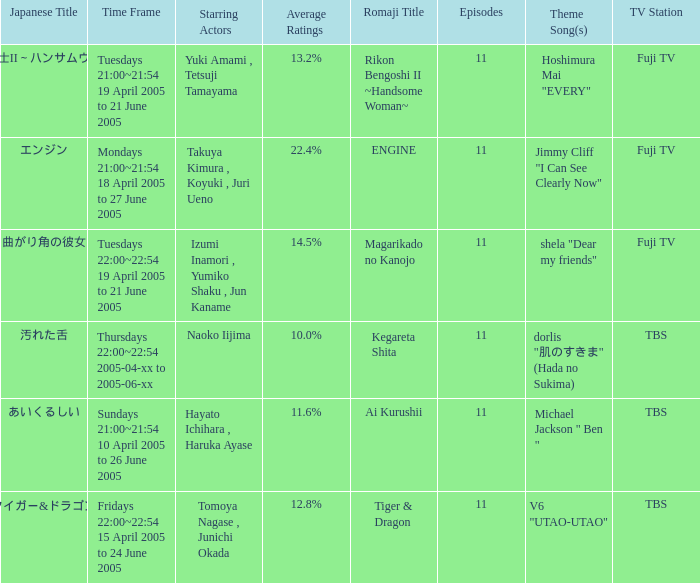What is maximum number of episodes for a show? 11.0. 